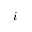<formula> <loc_0><loc_0><loc_500><loc_500>i</formula> 